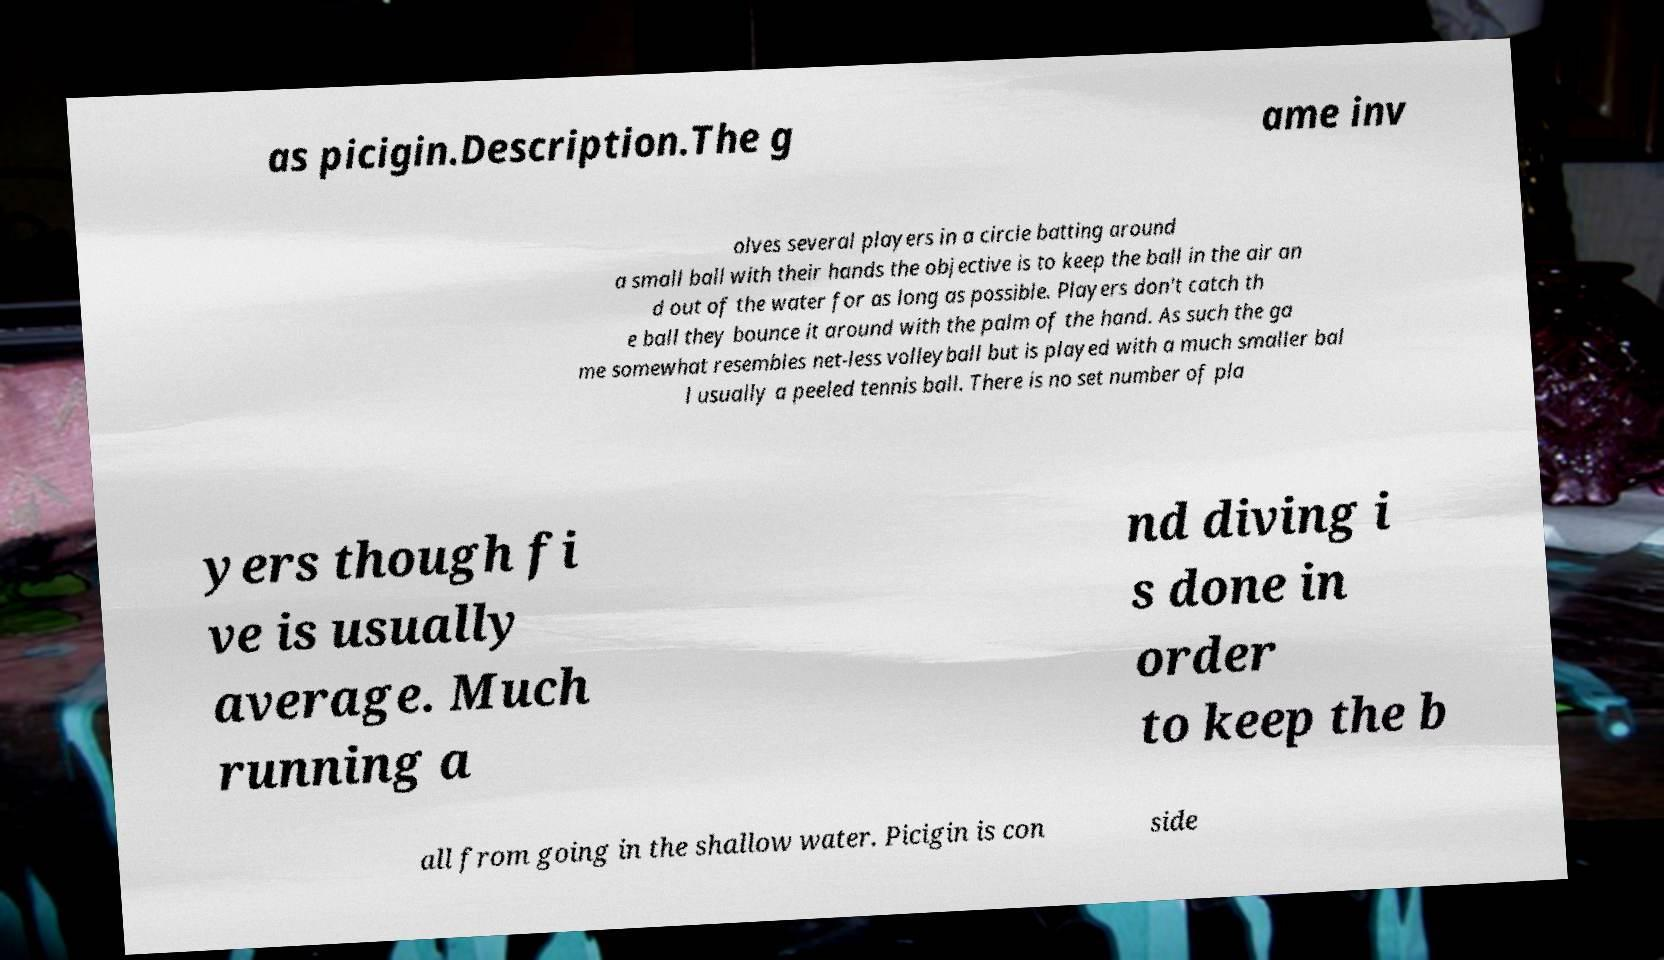Can you read and provide the text displayed in the image?This photo seems to have some interesting text. Can you extract and type it out for me? as picigin.Description.The g ame inv olves several players in a circle batting around a small ball with their hands the objective is to keep the ball in the air an d out of the water for as long as possible. Players don't catch th e ball they bounce it around with the palm of the hand. As such the ga me somewhat resembles net-less volleyball but is played with a much smaller bal l usually a peeled tennis ball. There is no set number of pla yers though fi ve is usually average. Much running a nd diving i s done in order to keep the b all from going in the shallow water. Picigin is con side 